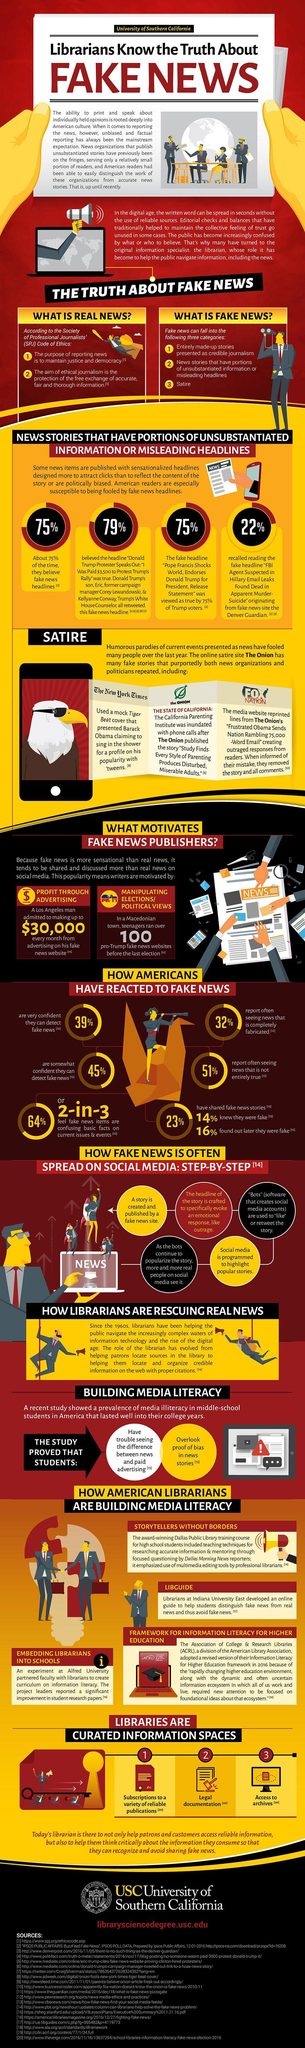What percentage of Americans are not very confident in detecting fake news?
Answer the question with a short phrase. 25% 